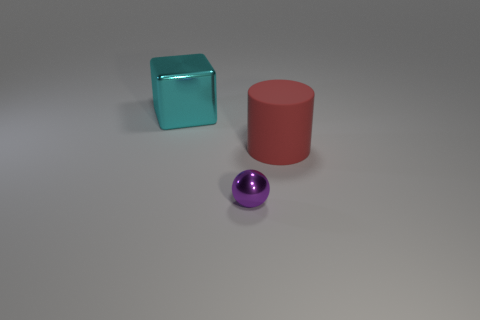Add 3 tiny red rubber things. How many objects exist? 6 Subtract all cubes. How many objects are left? 2 Subtract 1 cylinders. How many cylinders are left? 0 Subtract all matte cylinders. Subtract all purple shiny things. How many objects are left? 1 Add 3 big cubes. How many big cubes are left? 4 Add 2 large cyan matte balls. How many large cyan matte balls exist? 2 Subtract 0 yellow balls. How many objects are left? 3 Subtract all green balls. Subtract all purple blocks. How many balls are left? 1 